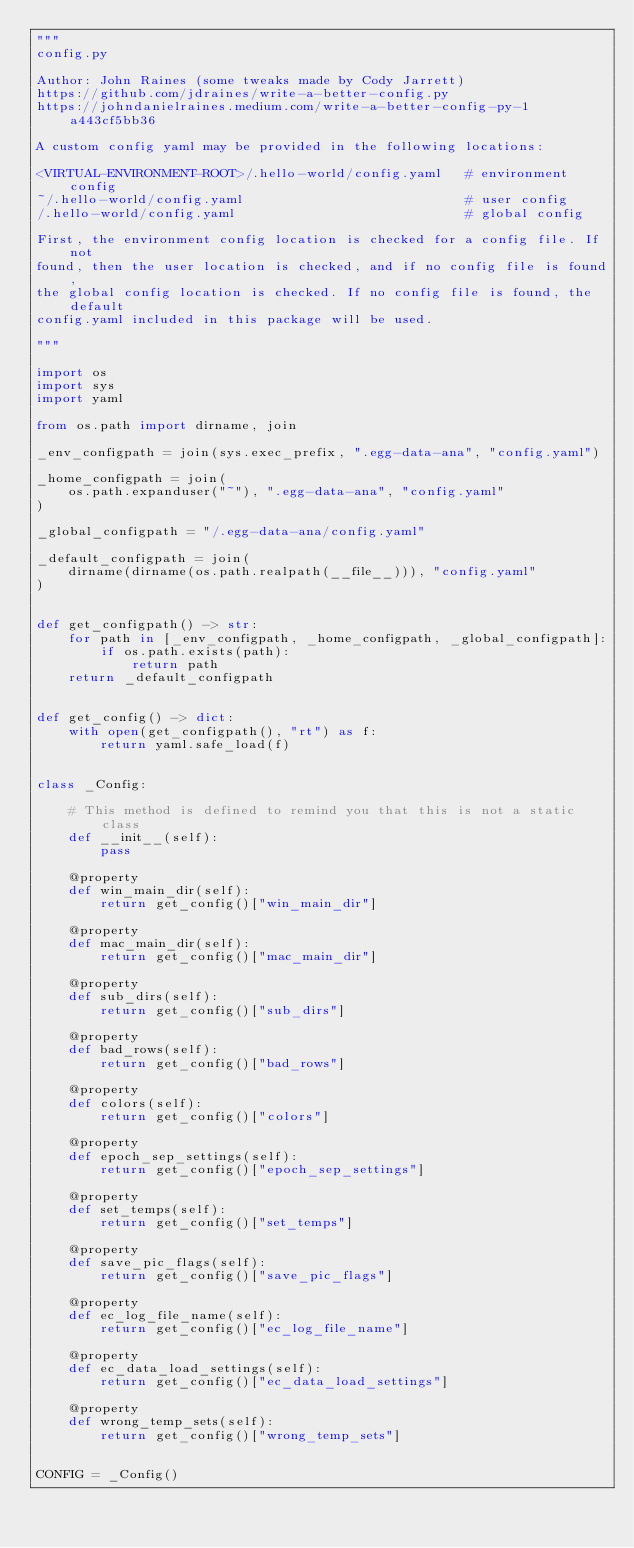Convert code to text. <code><loc_0><loc_0><loc_500><loc_500><_Python_>"""
config.py

Author: John Raines (some tweaks made by Cody Jarrett)
https://github.com/jdraines/write-a-better-config.py
https://johndanielraines.medium.com/write-a-better-config-py-1a443cf5bb36

A custom config yaml may be provided in the following locations:

<VIRTUAL-ENVIRONMENT-ROOT>/.hello-world/config.yaml   # environment config
~/.hello-world/config.yaml                            # user config
/.hello-world/config.yaml                             # global config

First, the environment config location is checked for a config file. If not
found, then the user location is checked, and if no config file is found,
the global config location is checked. If no config file is found, the default
config.yaml included in this package will be used.

"""

import os
import sys
import yaml

from os.path import dirname, join

_env_configpath = join(sys.exec_prefix, ".egg-data-ana", "config.yaml")

_home_configpath = join(
    os.path.expanduser("~"), ".egg-data-ana", "config.yaml"
)

_global_configpath = "/.egg-data-ana/config.yaml"

_default_configpath = join(
    dirname(dirname(os.path.realpath(__file__))), "config.yaml"
)


def get_configpath() -> str:
    for path in [_env_configpath, _home_configpath, _global_configpath]:
        if os.path.exists(path):
            return path
    return _default_configpath


def get_config() -> dict:
    with open(get_configpath(), "rt") as f:
        return yaml.safe_load(f)


class _Config:

    # This method is defined to remind you that this is not a static class
    def __init__(self):
        pass

    @property
    def win_main_dir(self):
        return get_config()["win_main_dir"]

    @property
    def mac_main_dir(self):
        return get_config()["mac_main_dir"]

    @property
    def sub_dirs(self):
        return get_config()["sub_dirs"]

    @property
    def bad_rows(self):
        return get_config()["bad_rows"]

    @property
    def colors(self):
        return get_config()["colors"]

    @property
    def epoch_sep_settings(self):
        return get_config()["epoch_sep_settings"]

    @property
    def set_temps(self):
        return get_config()["set_temps"]

    @property
    def save_pic_flags(self):
        return get_config()["save_pic_flags"]

    @property
    def ec_log_file_name(self):
        return get_config()["ec_log_file_name"]

    @property
    def ec_data_load_settings(self):
        return get_config()["ec_data_load_settings"]

    @property
    def wrong_temp_sets(self):
        return get_config()["wrong_temp_sets"]


CONFIG = _Config()
</code> 